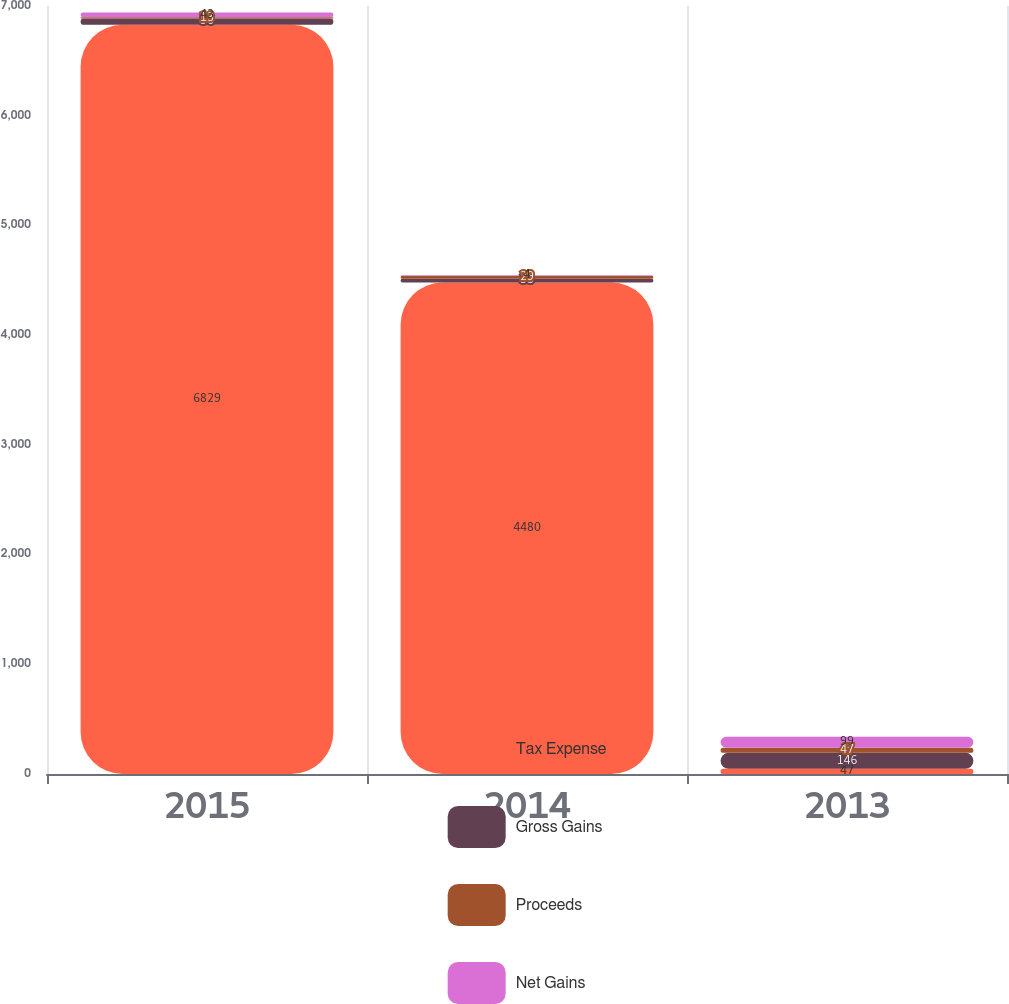<chart> <loc_0><loc_0><loc_500><loc_500><stacked_bar_chart><ecel><fcel>2015<fcel>2014<fcel>2013<nl><fcel>Tax Expense<fcel>6829<fcel>4480<fcel>47<nl><fcel>Gross Gains<fcel>56<fcel>33<fcel>146<nl><fcel>Proceeds<fcel>13<fcel>29<fcel>47<nl><fcel>Net Gains<fcel>43<fcel>4<fcel>99<nl></chart> 